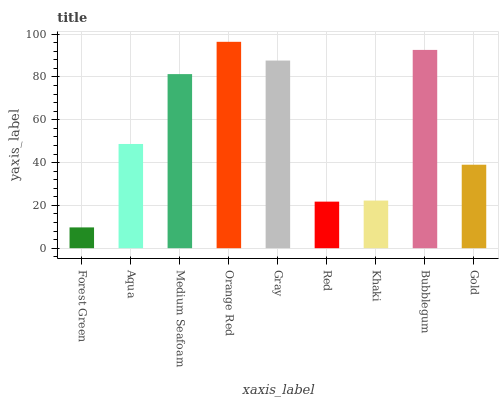Is Aqua the minimum?
Answer yes or no. No. Is Aqua the maximum?
Answer yes or no. No. Is Aqua greater than Forest Green?
Answer yes or no. Yes. Is Forest Green less than Aqua?
Answer yes or no. Yes. Is Forest Green greater than Aqua?
Answer yes or no. No. Is Aqua less than Forest Green?
Answer yes or no. No. Is Aqua the high median?
Answer yes or no. Yes. Is Aqua the low median?
Answer yes or no. Yes. Is Red the high median?
Answer yes or no. No. Is Medium Seafoam the low median?
Answer yes or no. No. 